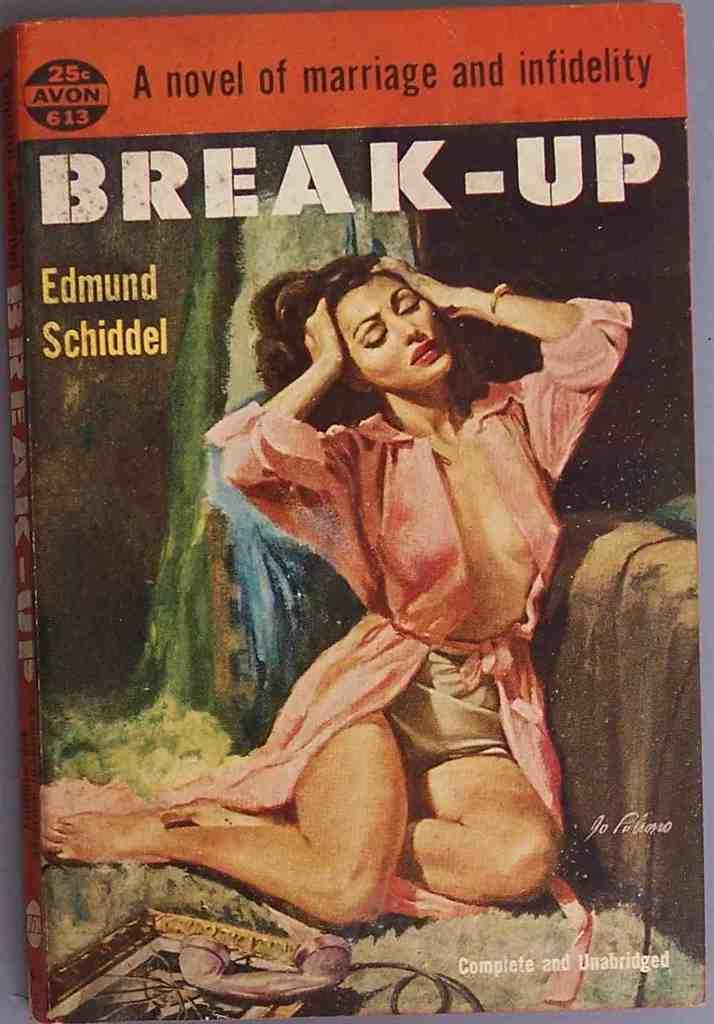What is the main subject of the image? The image contains the cover page of a book. Can you describe any specific details about the cover page? Unfortunately, the provided facts do not include any specific details about the cover page. What type of butter is being used for the observation in the image? There is no butter or observation present in the image; it contains the cover page of a book. 